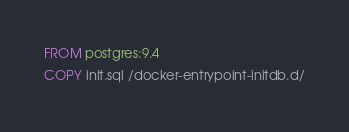<code> <loc_0><loc_0><loc_500><loc_500><_Dockerfile_>FROM postgres:9.4
COPY init.sql /docker-entrypoint-initdb.d/
</code> 